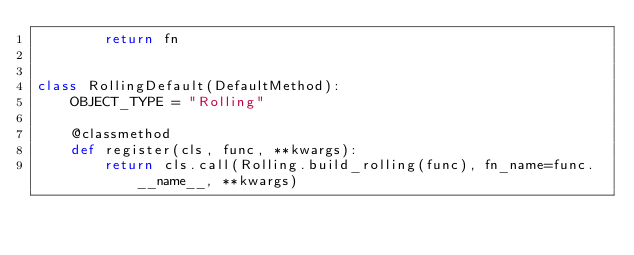<code> <loc_0><loc_0><loc_500><loc_500><_Python_>        return fn


class RollingDefault(DefaultMethod):
    OBJECT_TYPE = "Rolling"

    @classmethod
    def register(cls, func, **kwargs):
        return cls.call(Rolling.build_rolling(func), fn_name=func.__name__, **kwargs)
</code> 